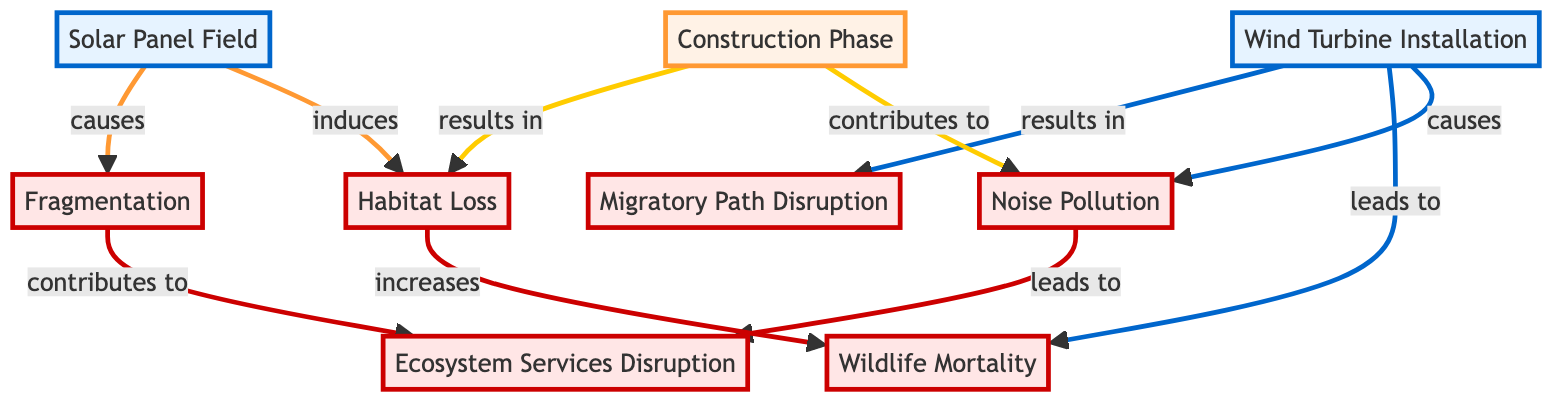What are the types of installations in the diagram? The diagram includes two types of installations: Wind Turbine Installation and Solar Panel Field. They are specifically categorized as installation nodes.
Answer: Wind Turbine Installation, Solar Panel Field How many impact nodes are there in the diagram? The impact nodes are Habitat Loss, Noise Pollution, Fragmentation, Wildlife Mortality, Migratory Path Disruption, and Ecosystem Services Disruption. There are a total of 6 impact nodes.
Answer: 6 What is the relationship between Wind Turbine Installation and Wildlife Mortality? The diagram shows that Wind Turbine Installation leads to Wildlife Mortality, indicated by the directed edge connecting the two nodes labeled "leads to."
Answer: leads to Which node results in Ecosystem Services Disruption? Ecosystem Services Disruption is reached from two nodes: Noise Pollution and Fragmentation. The diagram shows directed edges leading to Ecosystem Services Disruption from both.
Answer: Noise Pollution, Fragmentation Is there any node that contributes to both Noise Pollution and Habitat Loss? The Construction Phase contributes to both Noise Pollution and Habitat Loss, as indicated by the arrows from Construction Phase to these two impact nodes, showing a direct link for both relationships.
Answer: Construction Phase What increases Wildlife Mortality in the diagram? The diagram indicates that Habitat Loss increases Wildlife Mortality through a directed edge labeled "increases." Thus, the relation is established directly from Habitat Loss to Wildlife Mortality.
Answer: Habitat Loss Which installation induces Habitat Loss? The Solar Panel Field induces Habitat Loss, as per the directed edge from Solar Panel Field to Habitat Loss labeled "induces." This relationship directly specifies the action of inducing from the installation to the impact.
Answer: Solar Panel Field Can Ecoystem Services Disruption occur without Fragmentation? According to the diagram, Ecosystem Services Disruption can occur only if it is preceded by Noise Pollution or Fragmentation, as both are shown to lead to Ecosystem Services Disruption. Therefore, it cannot occur without referring to these connections.
Answer: No How many edges are there in the diagram? The diagram shows a total of 10 directed edges connecting the various nodes. Each edge represents a relationship between two nodes.
Answer: 10 